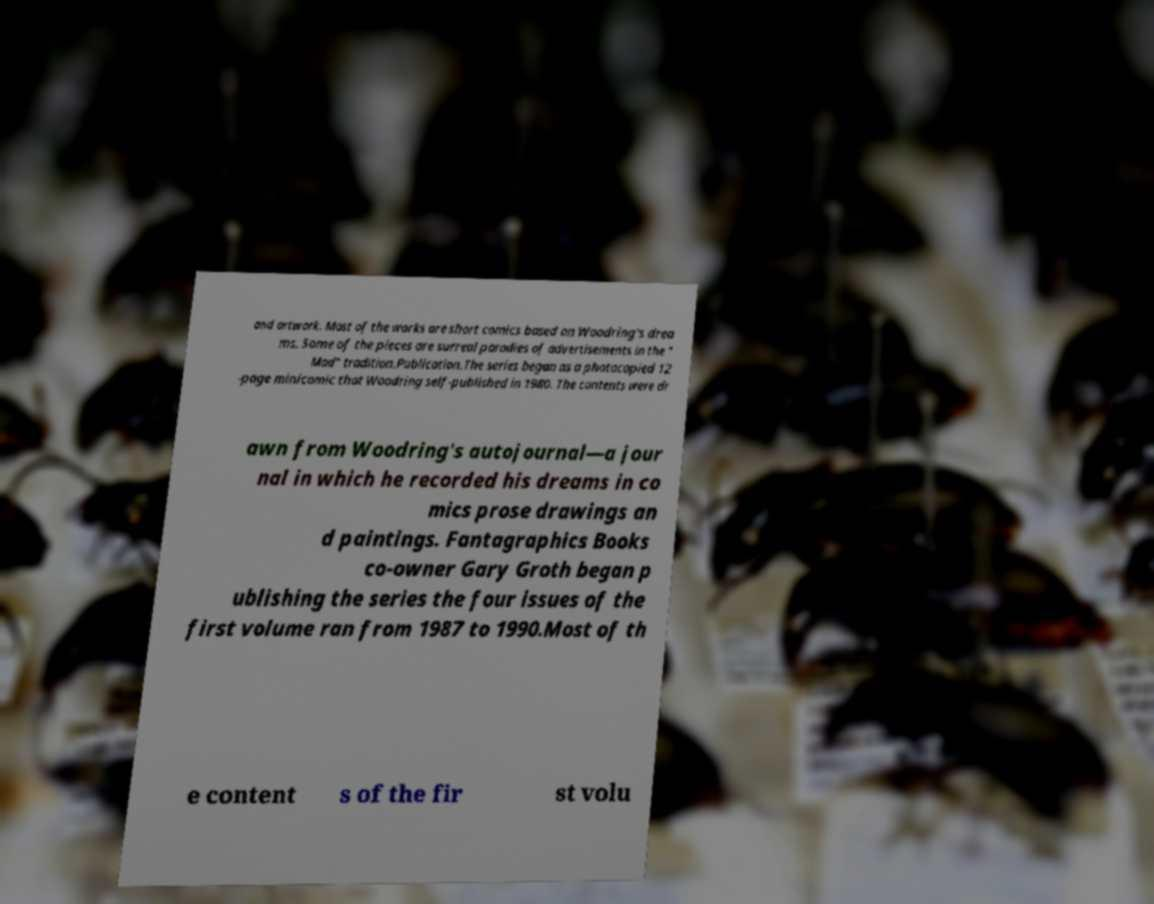I need the written content from this picture converted into text. Can you do that? and artwork. Most of the works are short comics based on Woodring's drea ms. Some of the pieces are surreal parodies of advertisements in the " Mad" tradition.Publication.The series began as a photocopied 12 -page minicomic that Woodring self-published in 1980. The contents were dr awn from Woodring's autojournal—a jour nal in which he recorded his dreams in co mics prose drawings an d paintings. Fantagraphics Books co-owner Gary Groth began p ublishing the series the four issues of the first volume ran from 1987 to 1990.Most of th e content s of the fir st volu 